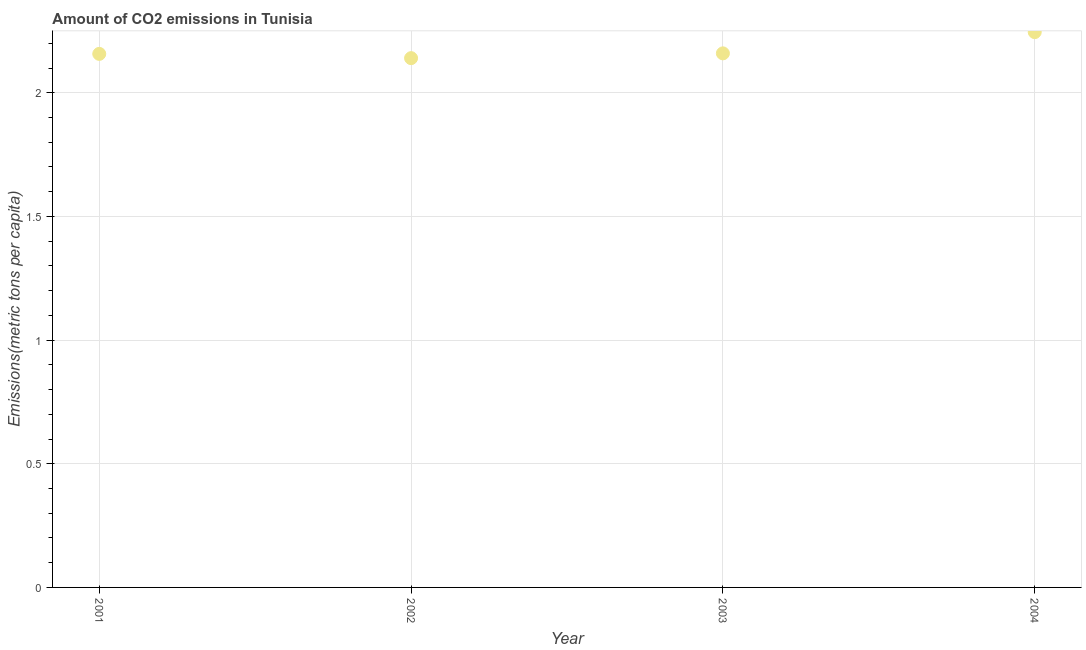What is the amount of co2 emissions in 2002?
Make the answer very short. 2.14. Across all years, what is the maximum amount of co2 emissions?
Ensure brevity in your answer.  2.25. Across all years, what is the minimum amount of co2 emissions?
Offer a terse response. 2.14. In which year was the amount of co2 emissions maximum?
Your answer should be compact. 2004. In which year was the amount of co2 emissions minimum?
Make the answer very short. 2002. What is the sum of the amount of co2 emissions?
Ensure brevity in your answer.  8.7. What is the difference between the amount of co2 emissions in 2002 and 2004?
Keep it short and to the point. -0.11. What is the average amount of co2 emissions per year?
Ensure brevity in your answer.  2.18. What is the median amount of co2 emissions?
Provide a succinct answer. 2.16. What is the ratio of the amount of co2 emissions in 2001 to that in 2002?
Offer a terse response. 1.01. What is the difference between the highest and the second highest amount of co2 emissions?
Keep it short and to the point. 0.09. What is the difference between the highest and the lowest amount of co2 emissions?
Provide a succinct answer. 0.11. In how many years, is the amount of co2 emissions greater than the average amount of co2 emissions taken over all years?
Your response must be concise. 1. Does the amount of co2 emissions monotonically increase over the years?
Your answer should be compact. No. How many dotlines are there?
Your answer should be compact. 1. How many years are there in the graph?
Your response must be concise. 4. Are the values on the major ticks of Y-axis written in scientific E-notation?
Keep it short and to the point. No. What is the title of the graph?
Make the answer very short. Amount of CO2 emissions in Tunisia. What is the label or title of the X-axis?
Make the answer very short. Year. What is the label or title of the Y-axis?
Your answer should be very brief. Emissions(metric tons per capita). What is the Emissions(metric tons per capita) in 2001?
Provide a succinct answer. 2.16. What is the Emissions(metric tons per capita) in 2002?
Provide a succinct answer. 2.14. What is the Emissions(metric tons per capita) in 2003?
Offer a very short reply. 2.16. What is the Emissions(metric tons per capita) in 2004?
Ensure brevity in your answer.  2.25. What is the difference between the Emissions(metric tons per capita) in 2001 and 2002?
Make the answer very short. 0.02. What is the difference between the Emissions(metric tons per capita) in 2001 and 2003?
Your answer should be compact. -0. What is the difference between the Emissions(metric tons per capita) in 2001 and 2004?
Ensure brevity in your answer.  -0.09. What is the difference between the Emissions(metric tons per capita) in 2002 and 2003?
Provide a short and direct response. -0.02. What is the difference between the Emissions(metric tons per capita) in 2002 and 2004?
Offer a very short reply. -0.11. What is the difference between the Emissions(metric tons per capita) in 2003 and 2004?
Your answer should be compact. -0.09. What is the ratio of the Emissions(metric tons per capita) in 2001 to that in 2004?
Your response must be concise. 0.96. What is the ratio of the Emissions(metric tons per capita) in 2002 to that in 2003?
Provide a succinct answer. 0.99. What is the ratio of the Emissions(metric tons per capita) in 2002 to that in 2004?
Offer a terse response. 0.95. 